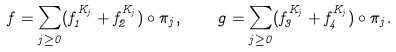Convert formula to latex. <formula><loc_0><loc_0><loc_500><loc_500>f = \sum _ { j \geq 0 } ( f _ { 1 } ^ { K _ { j } } + f _ { 2 } ^ { K _ { j } } ) \circ \pi _ { j } , \quad g = \sum _ { j \geq 0 } ( f _ { 3 } ^ { K _ { j } } + f _ { 4 } ^ { K _ { j } } ) \circ \pi _ { j } .</formula> 